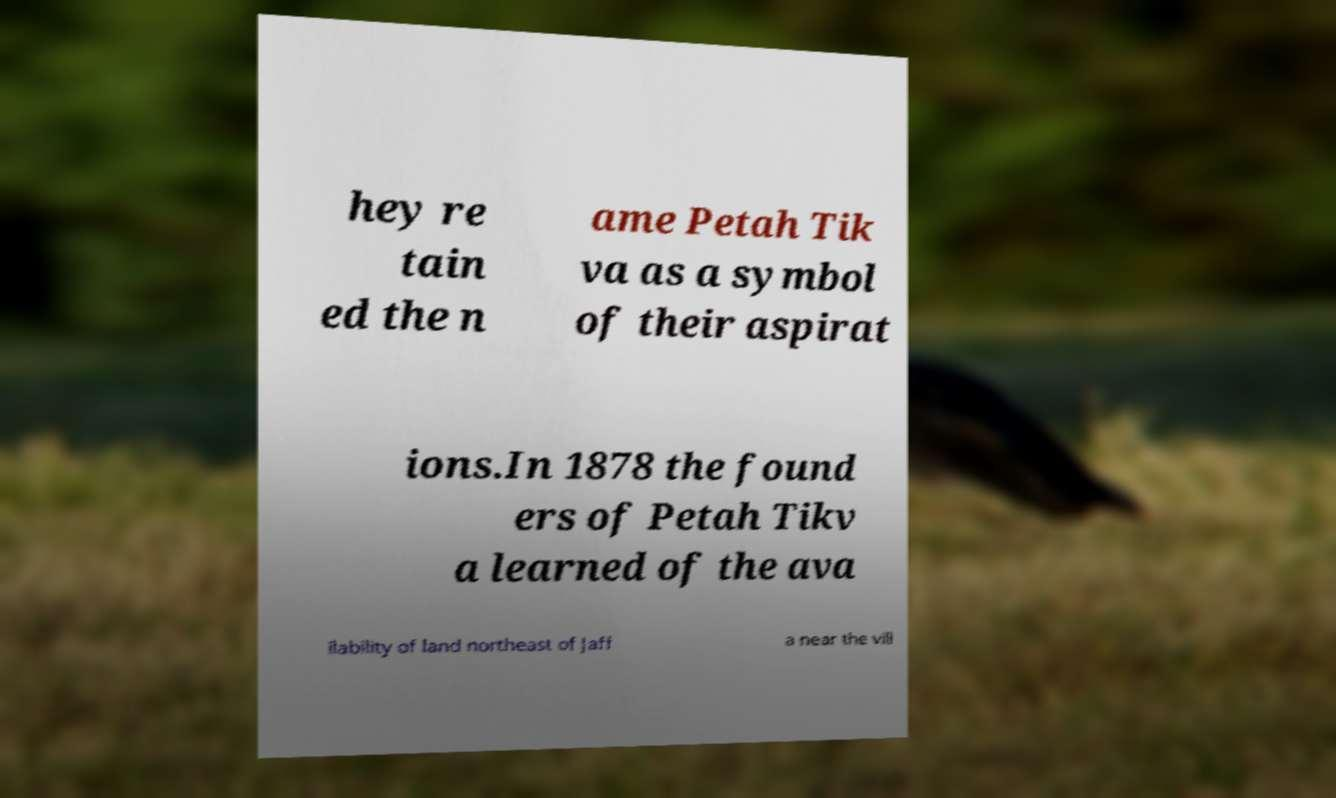Can you read and provide the text displayed in the image?This photo seems to have some interesting text. Can you extract and type it out for me? hey re tain ed the n ame Petah Tik va as a symbol of their aspirat ions.In 1878 the found ers of Petah Tikv a learned of the ava ilability of land northeast of Jaff a near the vill 